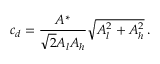Convert formula to latex. <formula><loc_0><loc_0><loc_500><loc_500>c _ { d } = \frac { A ^ { * } } { \sqrt { 2 } A _ { l } A _ { h } } \sqrt { A _ { l } ^ { 2 } + A _ { h } ^ { 2 } } \, .</formula> 